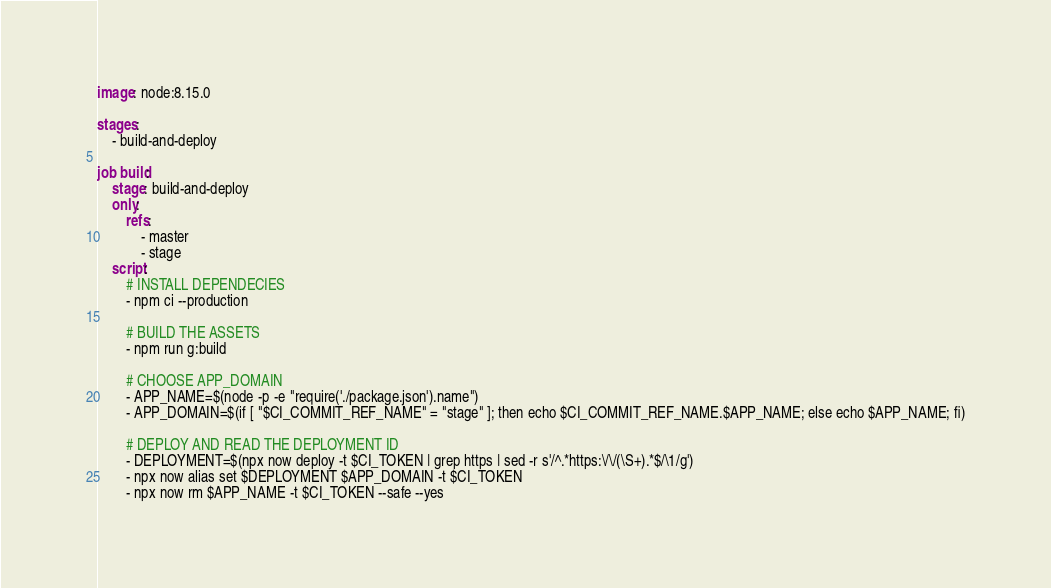Convert code to text. <code><loc_0><loc_0><loc_500><loc_500><_YAML_>image: node:8.15.0

stages:
    - build-and-deploy

job build:
    stage: build-and-deploy
    only:
        refs:
            - master
            - stage
    script:
        # INSTALL DEPENDECIES
        - npm ci --production

        # BUILD THE ASSETS
        - npm run g:build

        # CHOOSE APP_DOMAIN
        - APP_NAME=$(node -p -e "require('./package.json').name")
        - APP_DOMAIN=$(if [ "$CI_COMMIT_REF_NAME" = "stage" ]; then echo $CI_COMMIT_REF_NAME.$APP_NAME; else echo $APP_NAME; fi)

        # DEPLOY AND READ THE DEPLOYMENT ID
        - DEPLOYMENT=$(npx now deploy -t $CI_TOKEN | grep https | sed -r s'/^.*https:\/\/(\S+).*$/\1/g')
        - npx now alias set $DEPLOYMENT $APP_DOMAIN -t $CI_TOKEN
        - npx now rm $APP_NAME -t $CI_TOKEN --safe --yes
</code> 